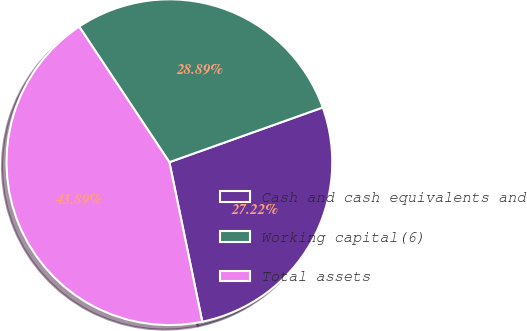Convert chart to OTSL. <chart><loc_0><loc_0><loc_500><loc_500><pie_chart><fcel>Cash and cash equivalents and<fcel>Working capital(6)<fcel>Total assets<nl><fcel>27.22%<fcel>28.89%<fcel>43.89%<nl></chart> 